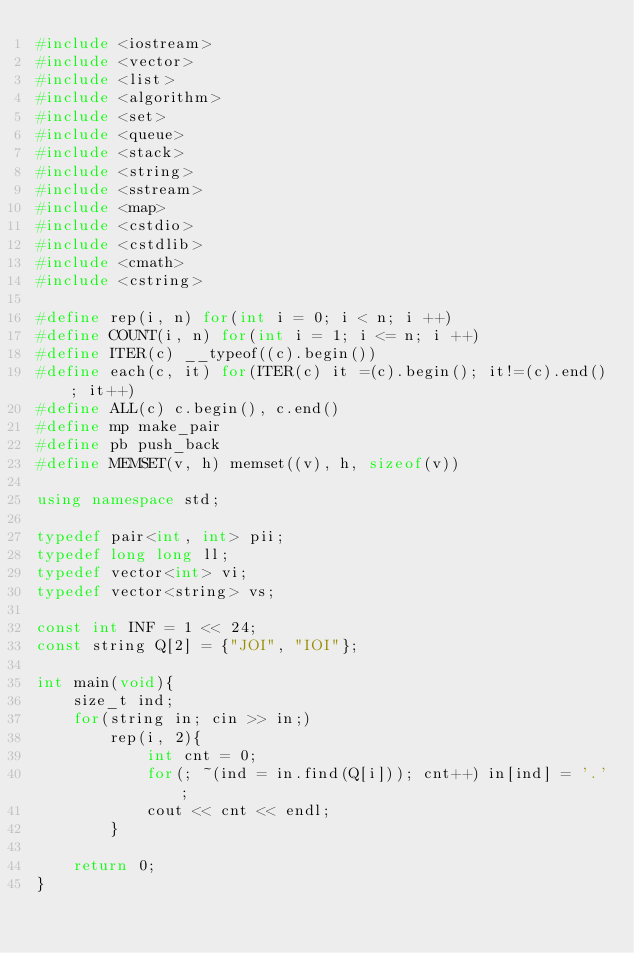<code> <loc_0><loc_0><loc_500><loc_500><_C++_>#include <iostream>
#include <vector>
#include <list>
#include <algorithm>
#include <set>
#include <queue>
#include <stack>
#include <string>
#include <sstream>
#include <map>
#include <cstdio>
#include <cstdlib>
#include <cmath>
#include <cstring>

#define rep(i, n) for(int i = 0; i < n; i ++)
#define COUNT(i, n) for(int i = 1; i <= n; i ++)
#define ITER(c) __typeof((c).begin())
#define each(c, it) for(ITER(c) it =(c).begin(); it!=(c).end(); it++)
#define ALL(c) c.begin(), c.end()
#define mp make_pair
#define pb push_back
#define MEMSET(v, h) memset((v), h, sizeof(v))
 
using namespace std; 

typedef pair<int, int> pii;
typedef long long ll;
typedef vector<int> vi;
typedef vector<string> vs;

const int INF = 1 << 24;
const string Q[2] = {"JOI", "IOI"};

int main(void){
    size_t ind;
    for(string in; cin >> in;)
        rep(i, 2){
            int cnt = 0;
            for(; ~(ind = in.find(Q[i])); cnt++) in[ind] = '.';
            cout << cnt << endl;
        }

    return 0;
}</code> 